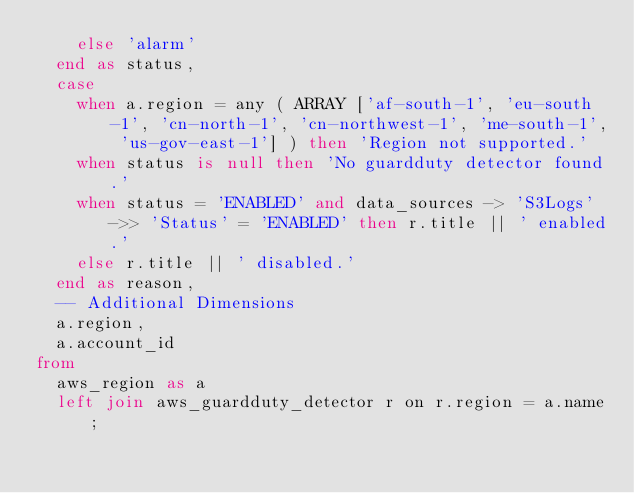Convert code to text. <code><loc_0><loc_0><loc_500><loc_500><_SQL_>    else 'alarm'
  end as status,
  case
    when a.region = any ( ARRAY ['af-south-1', 'eu-south-1', 'cn-north-1', 'cn-northwest-1', 'me-south-1', 'us-gov-east-1'] ) then 'Region not supported.'
    when status is null then 'No guardduty detector found.'
    when status = 'ENABLED' and data_sources -> 'S3Logs' ->> 'Status' = 'ENABLED' then r.title || ' enabled.'
    else r.title || ' disabled.'
  end as reason,
  -- Additional Dimensions
  a.region,
  a.account_id
from
  aws_region as a
  left join aws_guardduty_detector r on r.region = a.name;</code> 